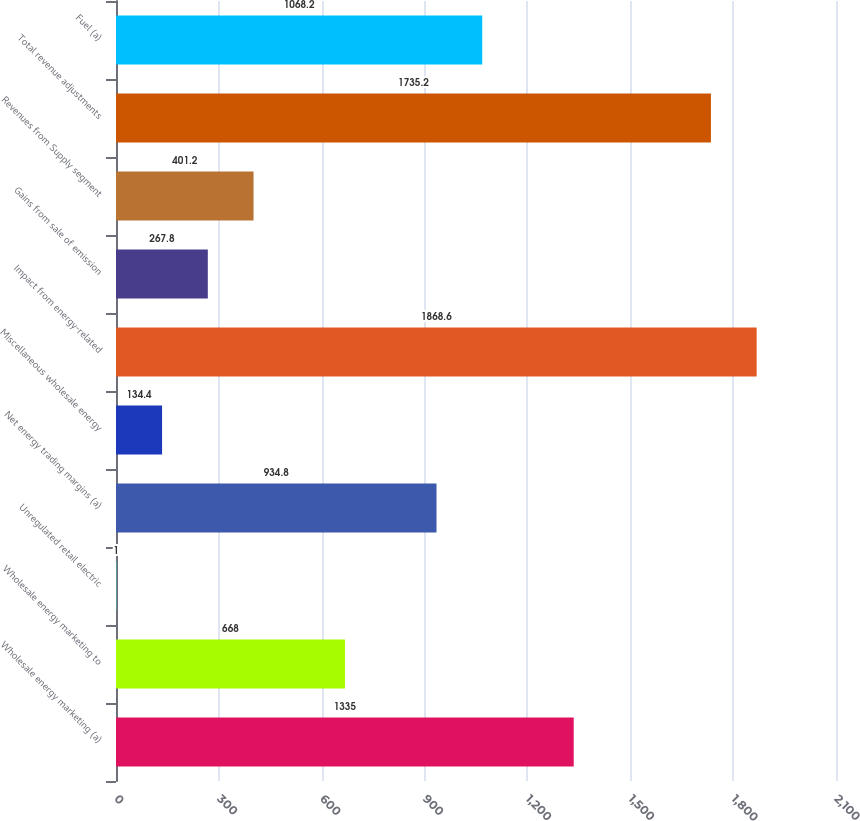Convert chart to OTSL. <chart><loc_0><loc_0><loc_500><loc_500><bar_chart><fcel>Wholesale energy marketing (a)<fcel>Wholesale energy marketing to<fcel>Unregulated retail electric<fcel>Net energy trading margins (a)<fcel>Miscellaneous wholesale energy<fcel>Impact from energy-related<fcel>Gains from sale of emission<fcel>Revenues from Supply segment<fcel>Total revenue adjustments<fcel>Fuel (a)<nl><fcel>1335<fcel>668<fcel>1<fcel>934.8<fcel>134.4<fcel>1868.6<fcel>267.8<fcel>401.2<fcel>1735.2<fcel>1068.2<nl></chart> 